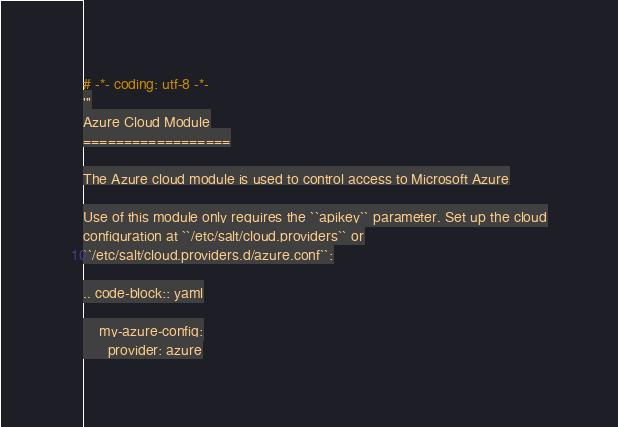Convert code to text. <code><loc_0><loc_0><loc_500><loc_500><_Python_># -*- coding: utf-8 -*-
'''
Azure Cloud Module
==================

The Azure cloud module is used to control access to Microsoft Azure

Use of this module only requires the ``apikey`` parameter. Set up the cloud
configuration at ``/etc/salt/cloud.providers`` or
``/etc/salt/cloud.providers.d/azure.conf``:

.. code-block:: yaml

    my-azure-config:
      provider: azure</code> 